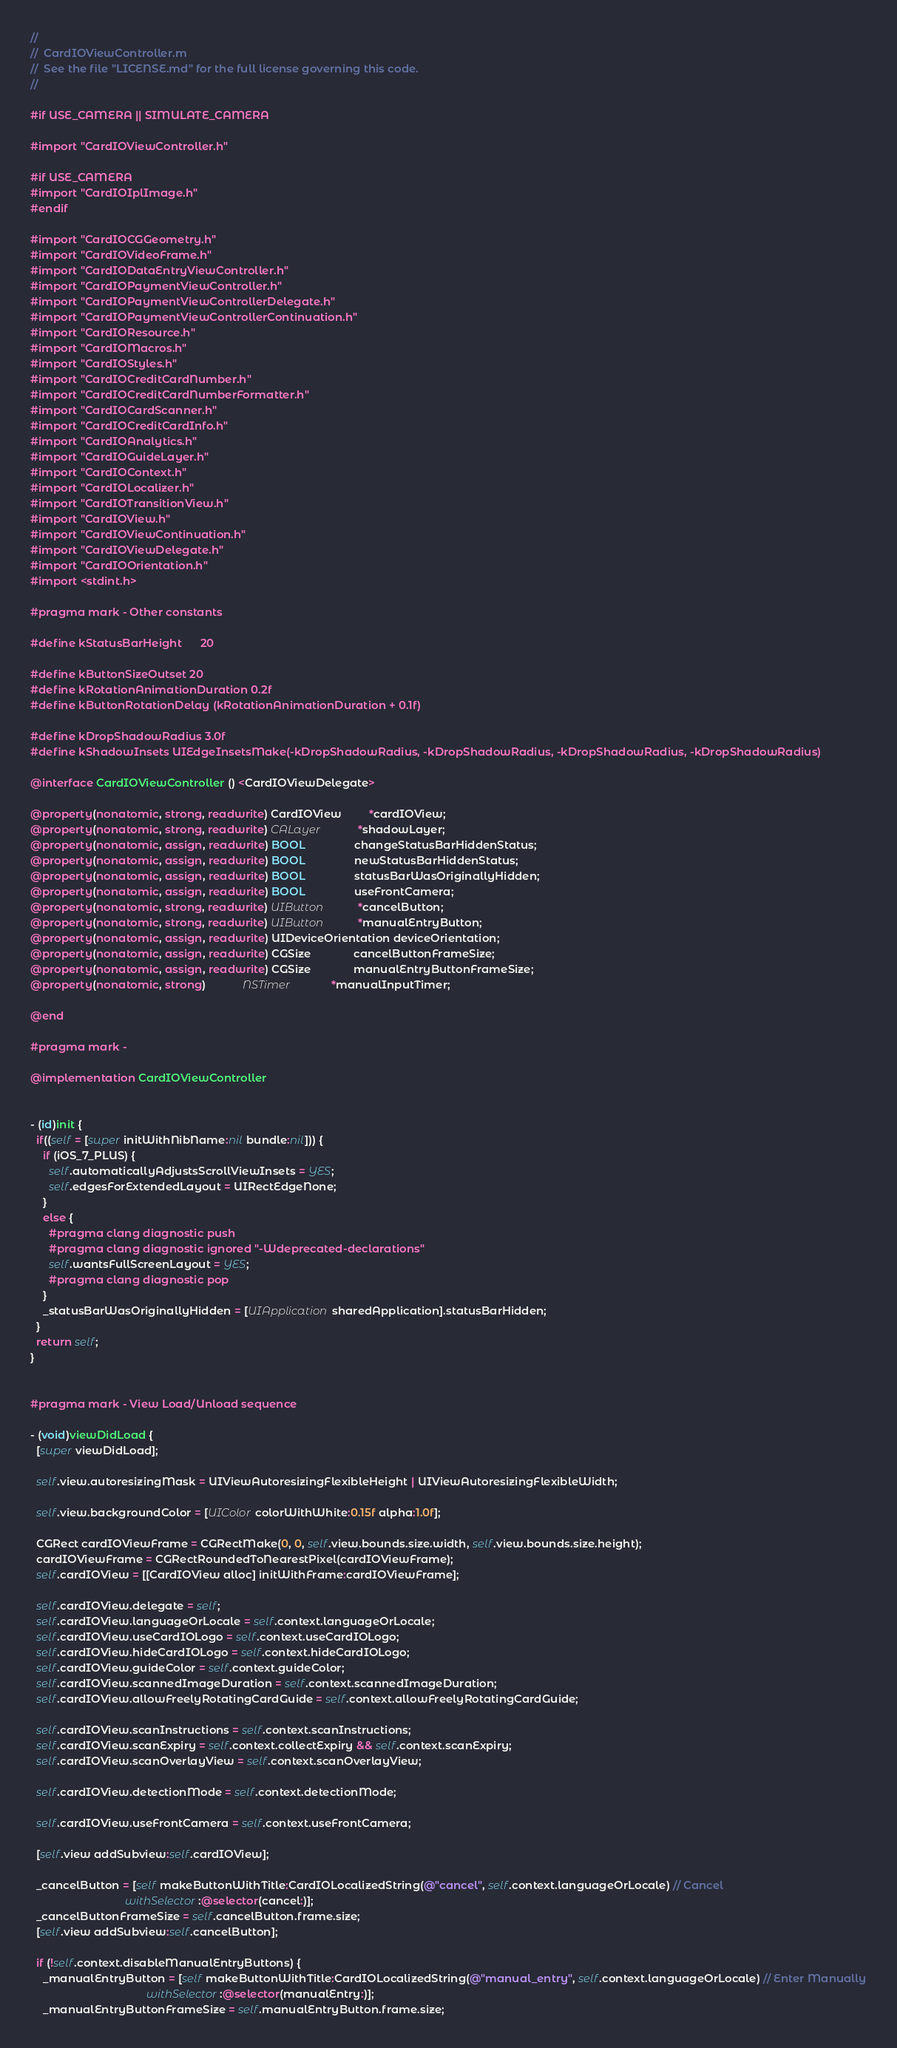<code> <loc_0><loc_0><loc_500><loc_500><_ObjectiveC_>//
//  CardIOViewController.m
//  See the file "LICENSE.md" for the full license governing this code.
//

#if USE_CAMERA || SIMULATE_CAMERA

#import "CardIOViewController.h"

#if USE_CAMERA
#import "CardIOIplImage.h"
#endif

#import "CardIOCGGeometry.h"
#import "CardIOVideoFrame.h"
#import "CardIODataEntryViewController.h"
#import "CardIOPaymentViewController.h"
#import "CardIOPaymentViewControllerDelegate.h"
#import "CardIOPaymentViewControllerContinuation.h"
#import "CardIOResource.h"
#import "CardIOMacros.h"
#import "CardIOStyles.h"
#import "CardIOCreditCardNumber.h"
#import "CardIOCreditCardNumberFormatter.h"
#import "CardIOCardScanner.h"
#import "CardIOCreditCardInfo.h"
#import "CardIOAnalytics.h"
#import "CardIOGuideLayer.h"
#import "CardIOContext.h"
#import "CardIOLocalizer.h"
#import "CardIOTransitionView.h"
#import "CardIOView.h"
#import "CardIOViewContinuation.h"
#import "CardIOViewDelegate.h"
#import "CardIOOrientation.h"
#import <stdint.h>

#pragma mark - Other constants

#define kStatusBarHeight      20

#define kButtonSizeOutset 20
#define kRotationAnimationDuration 0.2f
#define kButtonRotationDelay (kRotationAnimationDuration + 0.1f)

#define kDropShadowRadius 3.0f
#define kShadowInsets UIEdgeInsetsMake(-kDropShadowRadius, -kDropShadowRadius, -kDropShadowRadius, -kDropShadowRadius)

@interface CardIOViewController () <CardIOViewDelegate>

@property(nonatomic, strong, readwrite) CardIOView         *cardIOView;
@property(nonatomic, strong, readwrite) CALayer            *shadowLayer;
@property(nonatomic, assign, readwrite) BOOL                changeStatusBarHiddenStatus;
@property(nonatomic, assign, readwrite) BOOL                newStatusBarHiddenStatus;
@property(nonatomic, assign, readwrite) BOOL                statusBarWasOriginallyHidden;
@property(nonatomic, assign, readwrite) BOOL                useFrontCamera;
@property(nonatomic, strong, readwrite) UIButton           *cancelButton;
@property(nonatomic, strong, readwrite) UIButton           *manualEntryButton;
@property(nonatomic, assign, readwrite) UIDeviceOrientation deviceOrientation;
@property(nonatomic, assign, readwrite) CGSize              cancelButtonFrameSize;
@property(nonatomic, assign, readwrite) CGSize              manualEntryButtonFrameSize;
@property(nonatomic, strong)            NSTimer             *manualInputTimer;

@end

#pragma mark -

@implementation CardIOViewController


- (id)init {
  if((self = [super initWithNibName:nil bundle:nil])) {
    if (iOS_7_PLUS) {
      self.automaticallyAdjustsScrollViewInsets = YES;
      self.edgesForExtendedLayout = UIRectEdgeNone;
    }
    else {
      #pragma clang diagnostic push
      #pragma clang diagnostic ignored "-Wdeprecated-declarations"
      self.wantsFullScreenLayout = YES;
      #pragma clang diagnostic pop
    }
    _statusBarWasOriginallyHidden = [UIApplication sharedApplication].statusBarHidden;
  }
  return self;
}


#pragma mark - View Load/Unload sequence

- (void)viewDidLoad {
  [super viewDidLoad];
  
  self.view.autoresizingMask = UIViewAutoresizingFlexibleHeight | UIViewAutoresizingFlexibleWidth;

  self.view.backgroundColor = [UIColor colorWithWhite:0.15f alpha:1.0f];

  CGRect cardIOViewFrame = CGRectMake(0, 0, self.view.bounds.size.width, self.view.bounds.size.height);
  cardIOViewFrame = CGRectRoundedToNearestPixel(cardIOViewFrame);
  self.cardIOView = [[CardIOView alloc] initWithFrame:cardIOViewFrame];

  self.cardIOView.delegate = self;
  self.cardIOView.languageOrLocale = self.context.languageOrLocale;
  self.cardIOView.useCardIOLogo = self.context.useCardIOLogo;
  self.cardIOView.hideCardIOLogo = self.context.hideCardIOLogo;
  self.cardIOView.guideColor = self.context.guideColor;
  self.cardIOView.scannedImageDuration = self.context.scannedImageDuration;
  self.cardIOView.allowFreelyRotatingCardGuide = self.context.allowFreelyRotatingCardGuide;

  self.cardIOView.scanInstructions = self.context.scanInstructions;
  self.cardIOView.scanExpiry = self.context.collectExpiry && self.context.scanExpiry;
  self.cardIOView.scanOverlayView = self.context.scanOverlayView;

  self.cardIOView.detectionMode = self.context.detectionMode;
  
  self.cardIOView.useFrontCamera = self.context.useFrontCamera;

  [self.view addSubview:self.cardIOView];

  _cancelButton = [self makeButtonWithTitle:CardIOLocalizedString(@"cancel", self.context.languageOrLocale) // Cancel
                               withSelector:@selector(cancel:)];
  _cancelButtonFrameSize = self.cancelButton.frame.size;
  [self.view addSubview:self.cancelButton];

  if (!self.context.disableManualEntryButtons) {
    _manualEntryButton = [self makeButtonWithTitle:CardIOLocalizedString(@"manual_entry", self.context.languageOrLocale) // Enter Manually
                                      withSelector:@selector(manualEntry:)];
    _manualEntryButtonFrameSize = self.manualEntryButton.frame.size;</code> 